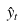<formula> <loc_0><loc_0><loc_500><loc_500>\hat { y } _ { t }</formula> 